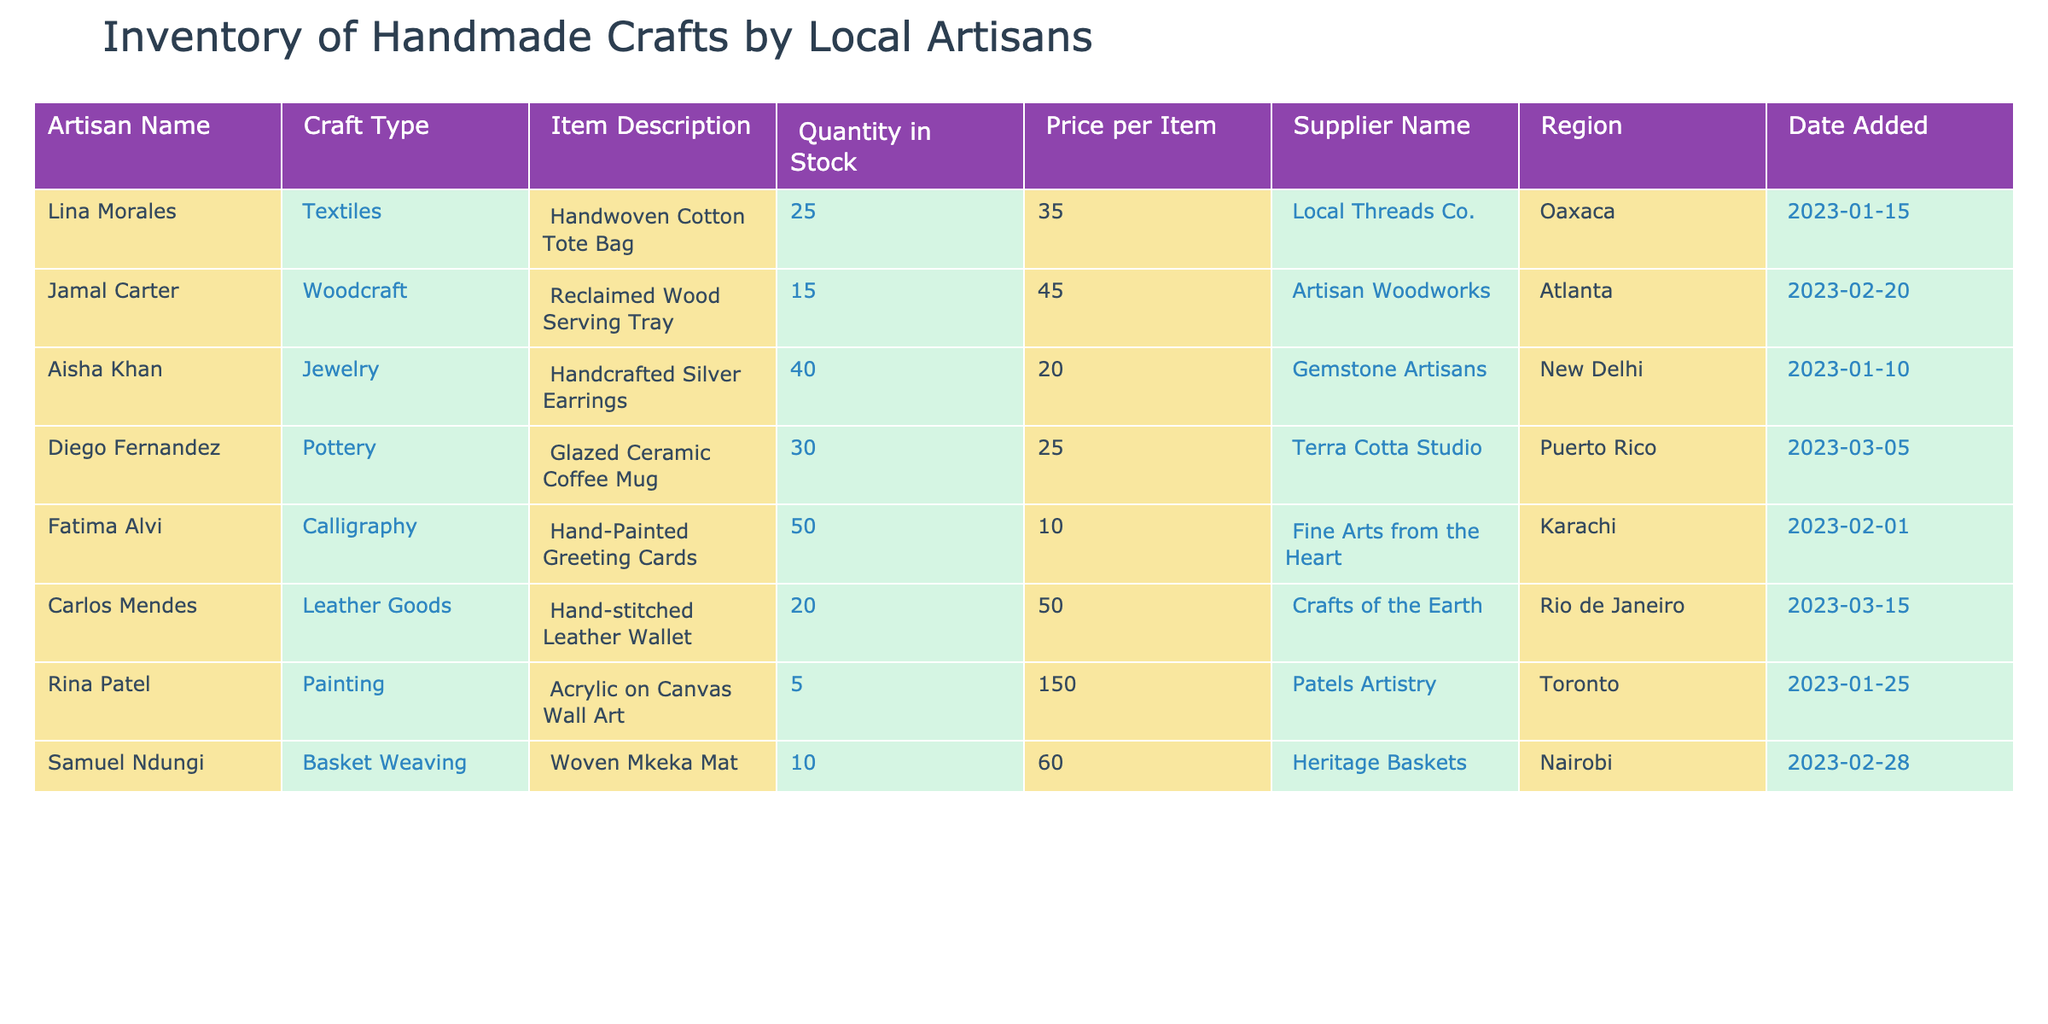What is the total quantity of items in stock for handmade crafts? To find the total quantity, I will sum up the values in the "Quantity in Stock" column. The quantities are 25 (Lina), 15 (Jamal), 40 (Aisha), 30 (Diego), 50 (Fatima), 20 (Carlos), 5 (Rina), and 10 (Samuel). Summing these gives: 25 + 15 + 40 + 30 + 50 + 20 + 5 + 10 = 195.
Answer: 195 Which artisan has the highest-priced item, and what is the price? I need to check the "Price per Item" column for each artisan and find the maximum value. The prices are 35.00 (Lina), 45.00 (Jamal), 20.00 (Aisha), 25.00 (Diego), 10.00 (Fatima), 50.00 (Carlos), 150.00 (Rina), and 60.00 (Samuel). The highest price is 150.00, which corresponds to Rina Patel.
Answer: Rina Patel, 150.00 Are there any items in stock by Diego Fernandez? I look for Diego Fernandez in the "Artisan Name" column, and his item "Glazed Ceramic Coffee Mug" has a quantity of 30 in stock. Since this is greater than zero, it confirms that he has items in stock.
Answer: Yes What is the average price of the crafts? To find the average price, I will sum all prices from the "Price per Item" column and then divide by the number of items. The prices are 35.00, 45.00, 20.00, 25.00, 10.00, 50.00, 150.00, and 60.00. The total price sum is: 35 + 45 + 20 + 25 + 10 + 50 + 150 + 60 = 395. The number of items is 8, so the average is 395 / 8 = 49.375.
Answer: 49.375 How many artisans are there from the region of Karachi? I will count the occurrences of "Karachi" in the "Region" column. The only artisan listed from Karachi is Fatima Alvi, indicating there is one artisan from that region.
Answer: 1 